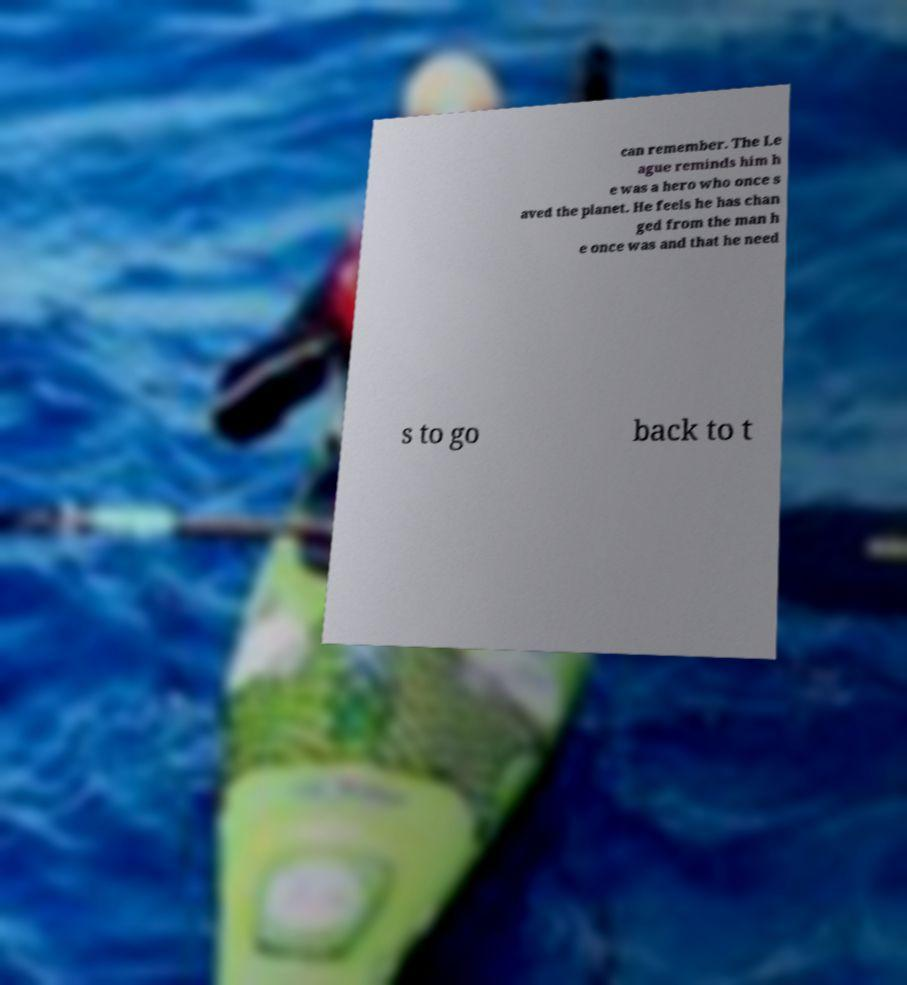Could you assist in decoding the text presented in this image and type it out clearly? can remember. The Le ague reminds him h e was a hero who once s aved the planet. He feels he has chan ged from the man h e once was and that he need s to go back to t 